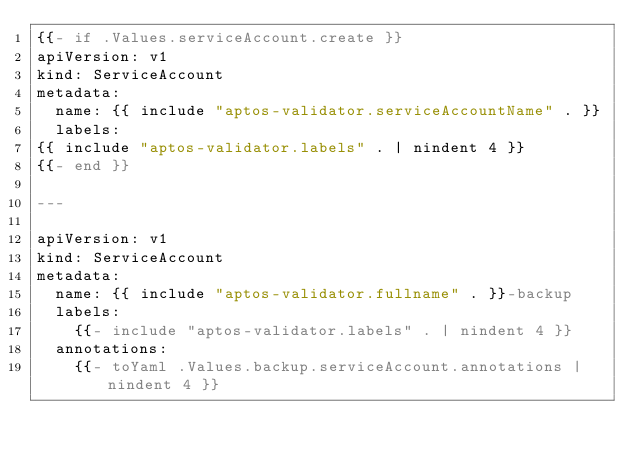Convert code to text. <code><loc_0><loc_0><loc_500><loc_500><_YAML_>{{- if .Values.serviceAccount.create }}
apiVersion: v1
kind: ServiceAccount
metadata:
  name: {{ include "aptos-validator.serviceAccountName" . }}
  labels:
{{ include "aptos-validator.labels" . | nindent 4 }}
{{- end }}

---

apiVersion: v1
kind: ServiceAccount
metadata:
  name: {{ include "aptos-validator.fullname" . }}-backup
  labels:
    {{- include "aptos-validator.labels" . | nindent 4 }}
  annotations:
    {{- toYaml .Values.backup.serviceAccount.annotations | nindent 4 }}
</code> 